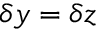Convert formula to latex. <formula><loc_0><loc_0><loc_500><loc_500>\delta y = \delta z</formula> 